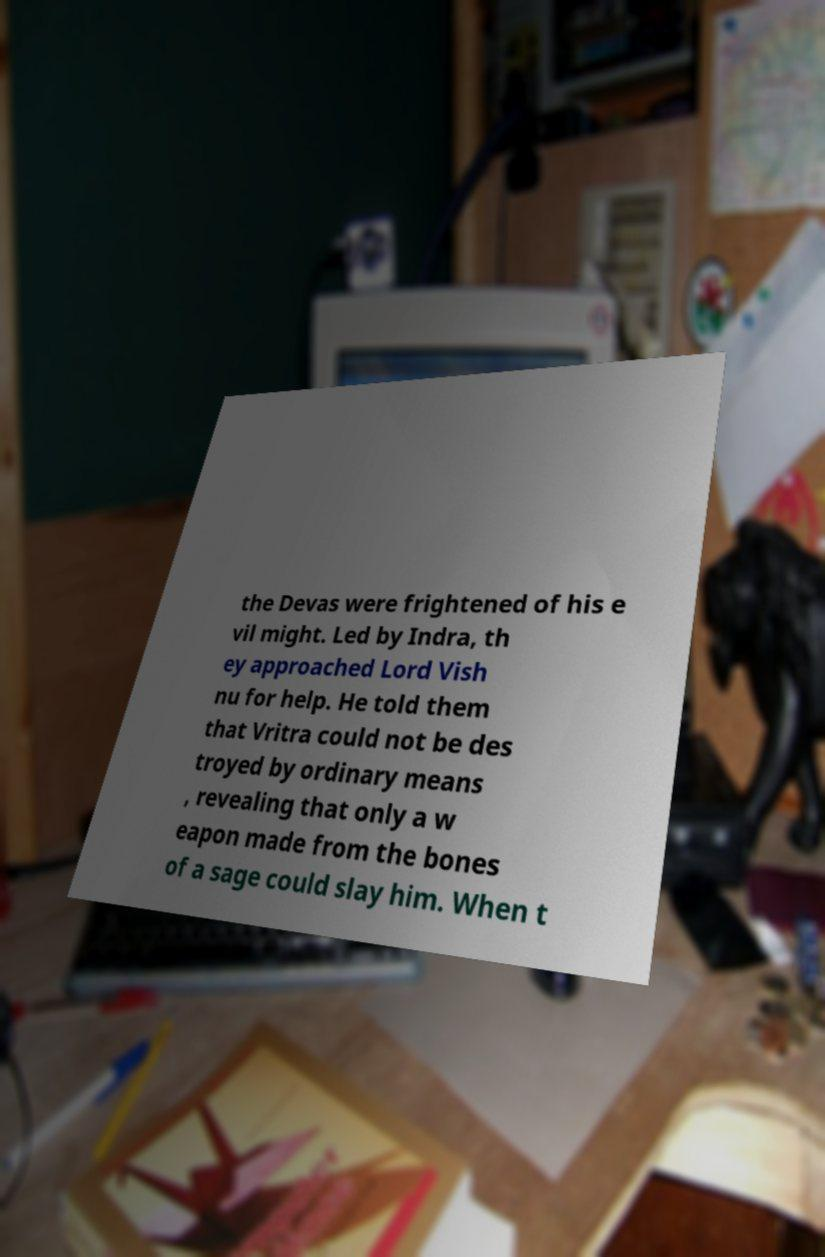Please read and relay the text visible in this image. What does it say? the Devas were frightened of his e vil might. Led by Indra, th ey approached Lord Vish nu for help. He told them that Vritra could not be des troyed by ordinary means , revealing that only a w eapon made from the bones of a sage could slay him. When t 